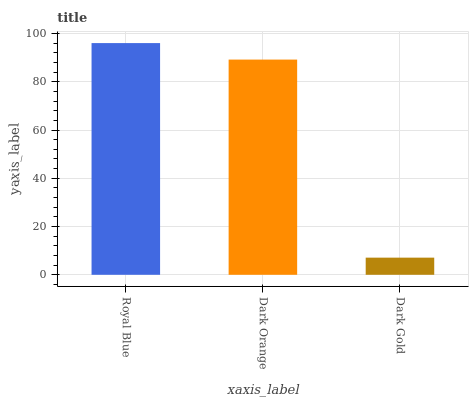Is Dark Orange the minimum?
Answer yes or no. No. Is Dark Orange the maximum?
Answer yes or no. No. Is Royal Blue greater than Dark Orange?
Answer yes or no. Yes. Is Dark Orange less than Royal Blue?
Answer yes or no. Yes. Is Dark Orange greater than Royal Blue?
Answer yes or no. No. Is Royal Blue less than Dark Orange?
Answer yes or no. No. Is Dark Orange the high median?
Answer yes or no. Yes. Is Dark Orange the low median?
Answer yes or no. Yes. Is Royal Blue the high median?
Answer yes or no. No. Is Royal Blue the low median?
Answer yes or no. No. 